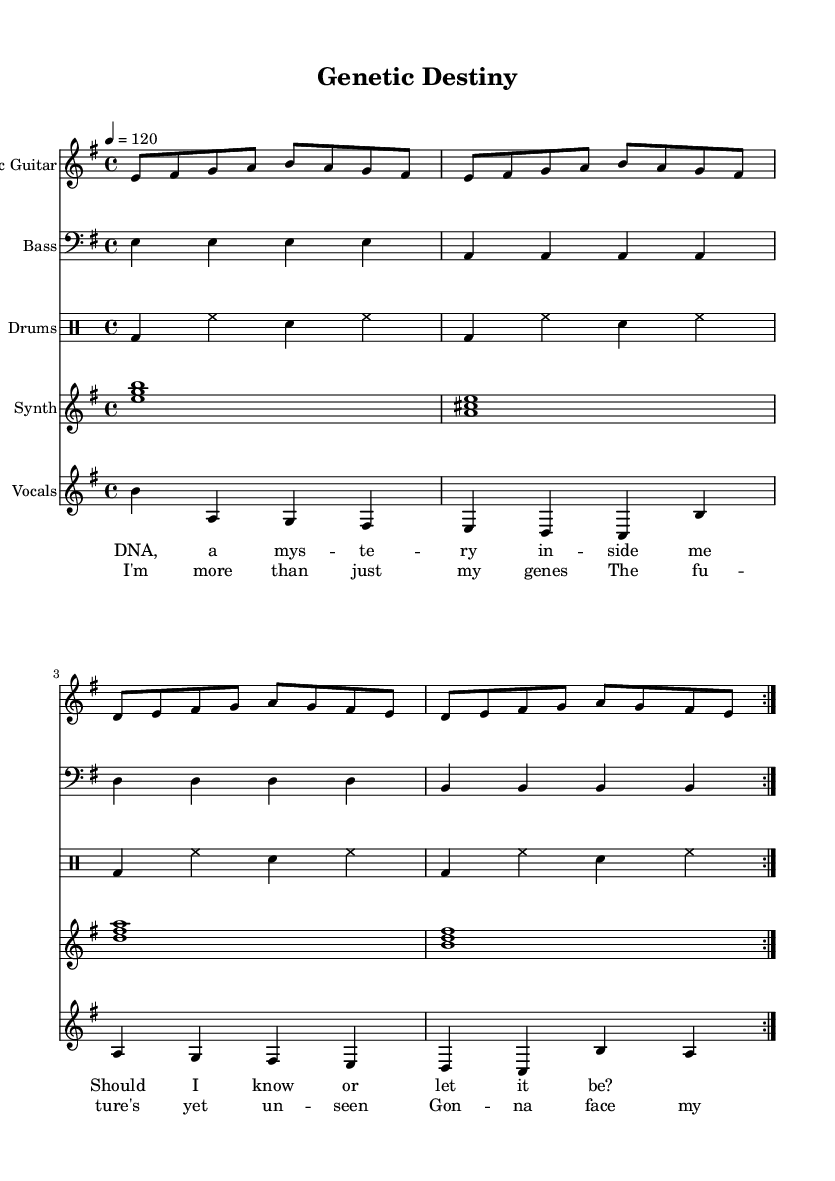What is the key signature of this music? The key is indicated at the beginning of the score; in this case, it shows two sharps, signifying E minor.
Answer: E minor What is the time signature of this piece? The time signature is noted right after the key signature. Here, it is 4/4, which signifies four beats in a measure.
Answer: 4/4 What is the tempo marking for this piece? Tempo markings are typically provided near the top of the score. In this case, it states "4 = 120," indicating the tempo is 120 beats per minute.
Answer: 120 How many times is the verse repeated? The verse section is written with "repeat volta 2," indicating that this section should be played twice.
Answer: 2 What type of instrument is playing the vocal part? The vocal part is noted under "Vocals" in the score, which clearly identifies that it is meant for voice.
Answer: Voice What chords are played in the synthesizer part? The chords are listed in block form across the measures; the synthesizer plays E minor, A major, D major, and B minor.
Answer: E minor, A major, D major, B minor How does the chorus relate to the verse in terms of lyrics? The lyrics for both sections are specified; the verse sets up the theme of uncertainty, while the chorus provides an empowering resolution, showing their thematic connection.
Answer: Empowering resolution 